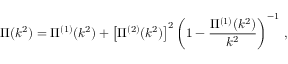Convert formula to latex. <formula><loc_0><loc_0><loc_500><loc_500>\Pi ( k ^ { 2 } ) = \Pi ^ { ( 1 ) } ( k ^ { 2 } ) + \left [ \Pi ^ { ( 2 ) } ( k ^ { 2 } ) \right ] ^ { 2 } \left ( 1 - \frac { \Pi ^ { ( 1 ) } ( k ^ { 2 } ) } { k ^ { 2 } } \right ) ^ { - 1 } \, ,</formula> 